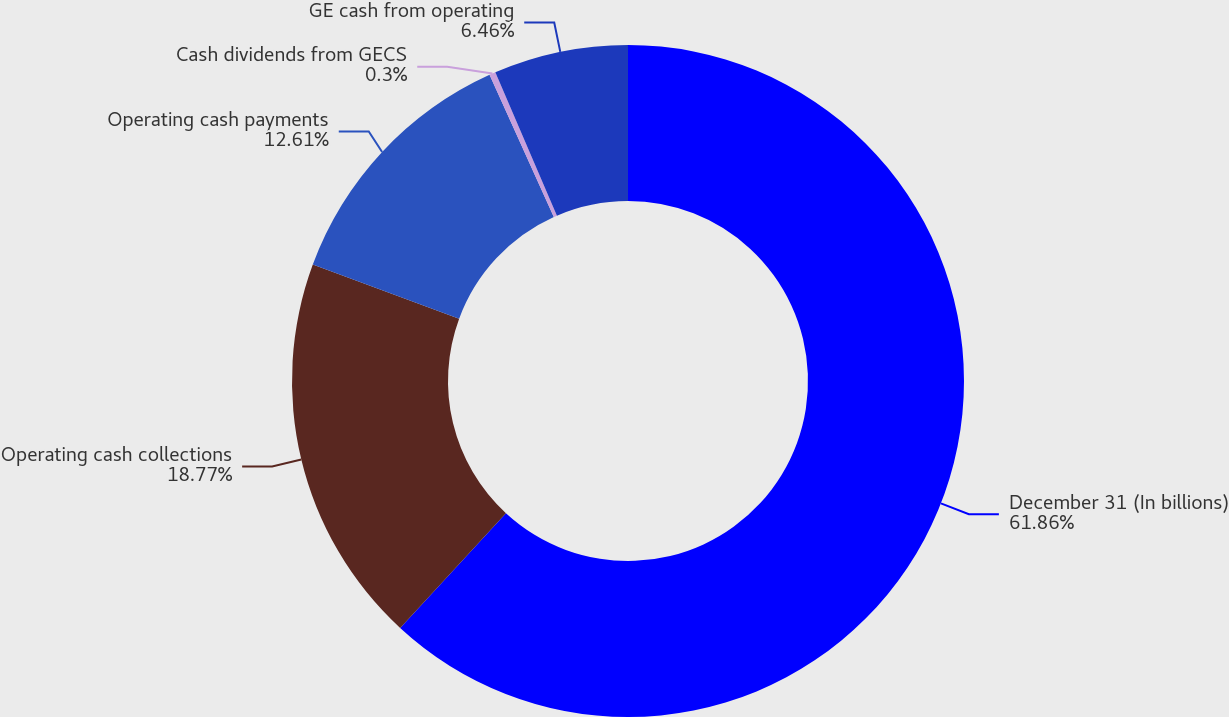Convert chart. <chart><loc_0><loc_0><loc_500><loc_500><pie_chart><fcel>December 31 (In billions)<fcel>Operating cash collections<fcel>Operating cash payments<fcel>Cash dividends from GECS<fcel>GE cash from operating<nl><fcel>61.86%<fcel>18.77%<fcel>12.61%<fcel>0.3%<fcel>6.46%<nl></chart> 